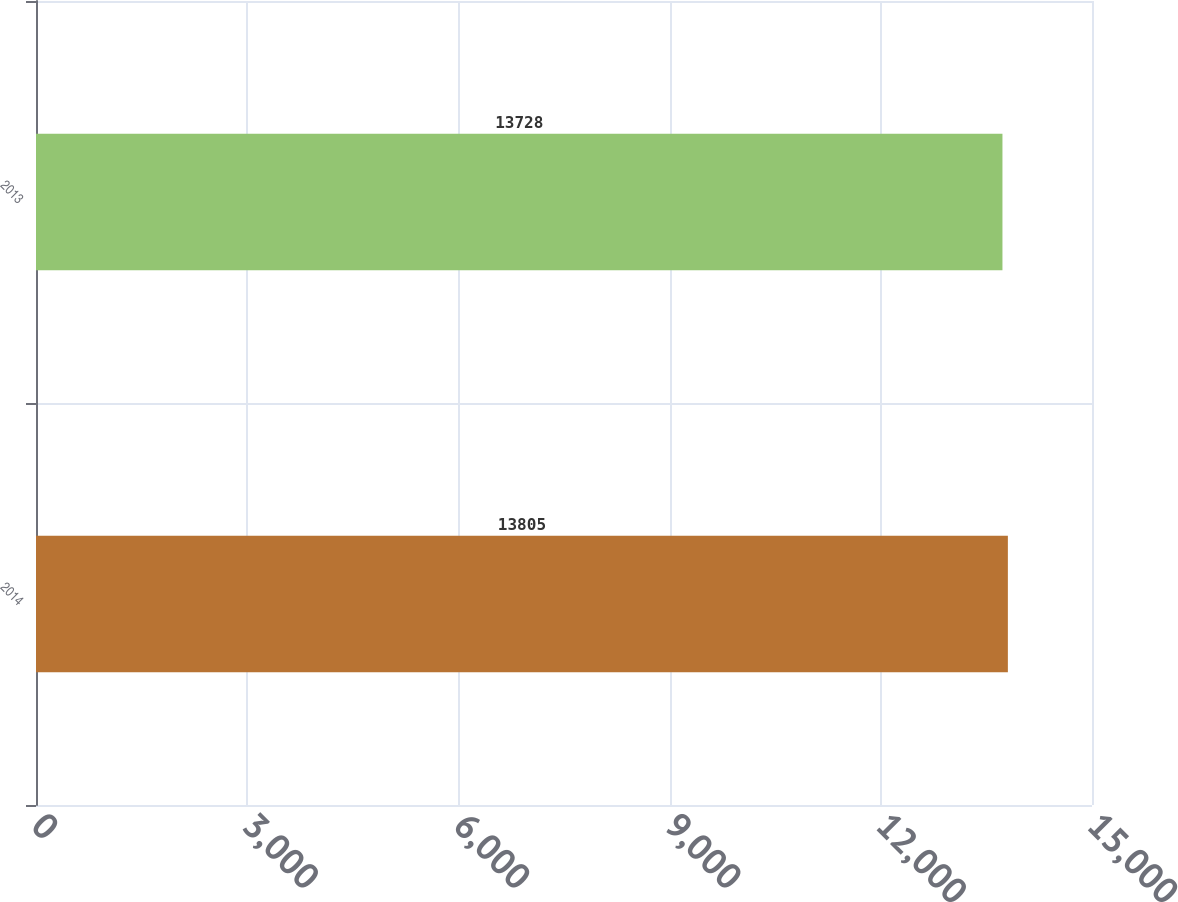Convert chart. <chart><loc_0><loc_0><loc_500><loc_500><bar_chart><fcel>2014<fcel>2013<nl><fcel>13805<fcel>13728<nl></chart> 